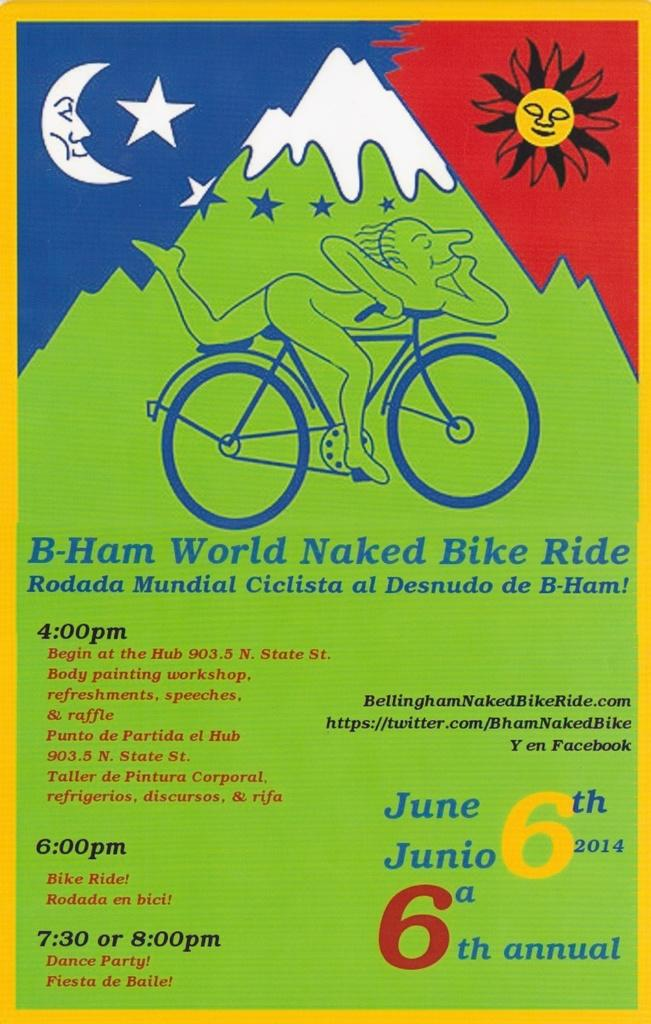<image>
Summarize the visual content of the image. Flyer featuring the B-ham world naked bike ride. 